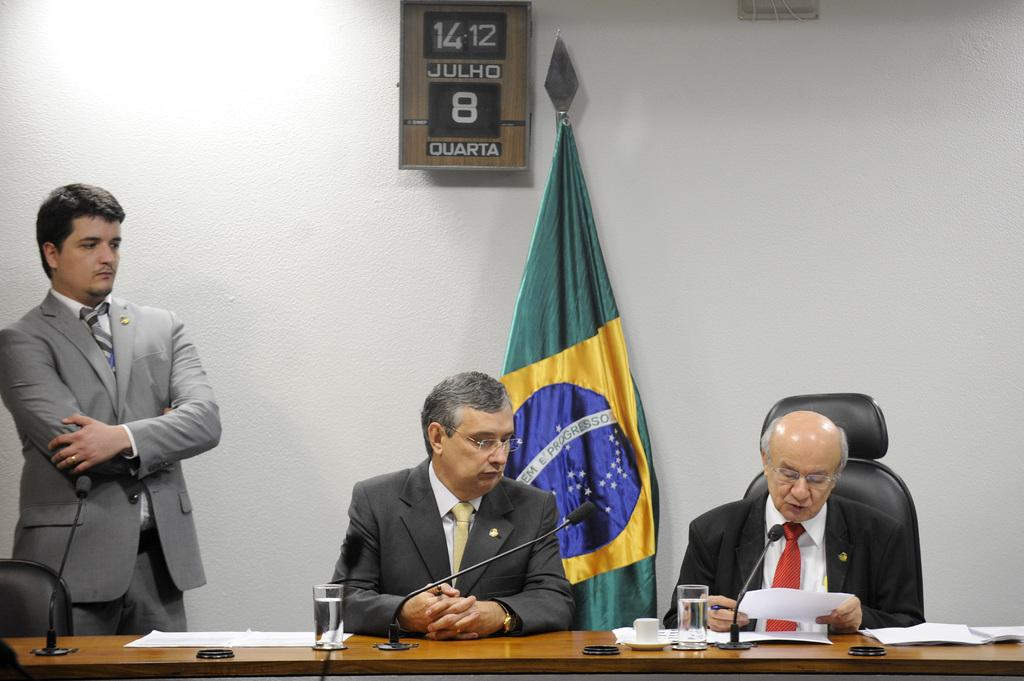What color is the wall in the image? The wall in the image is white. What can be seen flying or hanging in the image? There is a flag in the image. Who or what is present in the image? There are people in the image. What type of furniture is visible in the image? There are chairs and tables in the image. What is on top of the tables in the image? There are mice, papers, and glasses on the tables. What type of design can be seen on the plant in the image? There is no plant present in the image. What material is the brass used for in the image? There is no brass present in the image. 